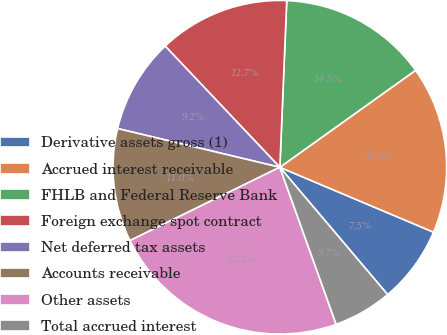Convert chart to OTSL. <chart><loc_0><loc_0><loc_500><loc_500><pie_chart><fcel>Derivative assets gross (1)<fcel>Accrued interest receivable<fcel>FHLB and Federal Reserve Bank<fcel>Foreign exchange spot contract<fcel>Net deferred tax assets<fcel>Accounts receivable<fcel>Other assets<fcel>Total accrued interest<nl><fcel>7.46%<fcel>16.23%<fcel>14.47%<fcel>12.72%<fcel>9.21%<fcel>10.97%<fcel>23.24%<fcel>5.7%<nl></chart> 